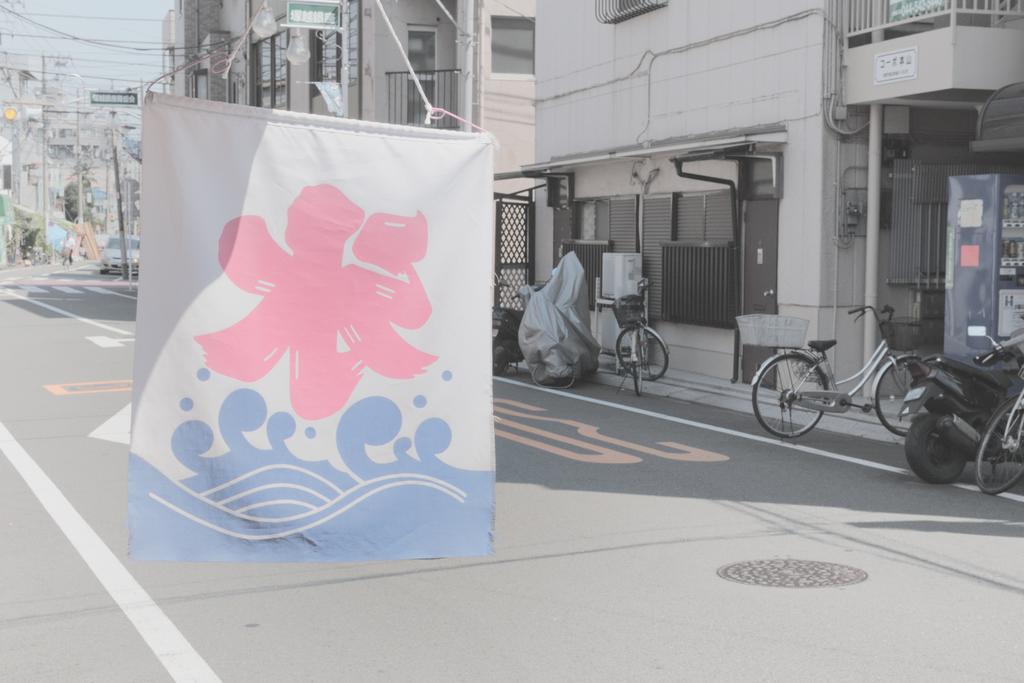Describe this image in one or two sentences. We can see banner with ropes and we can see road and vehicles are parking on the surface. In the background we can see buildings,wires,boards,windows and sky. 